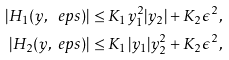<formula> <loc_0><loc_0><loc_500><loc_500>| H _ { 1 } ( y , \ e p s ) | & \leq K _ { 1 } y _ { 1 } ^ { 2 } | y _ { 2 } | + K _ { 2 } \epsilon ^ { 2 } , \\ | H _ { 2 } ( y , \ e p s ) | & \leq K _ { 1 } | y _ { 1 } | y _ { 2 } ^ { 2 } + K _ { 2 } \epsilon ^ { 2 } ,</formula> 